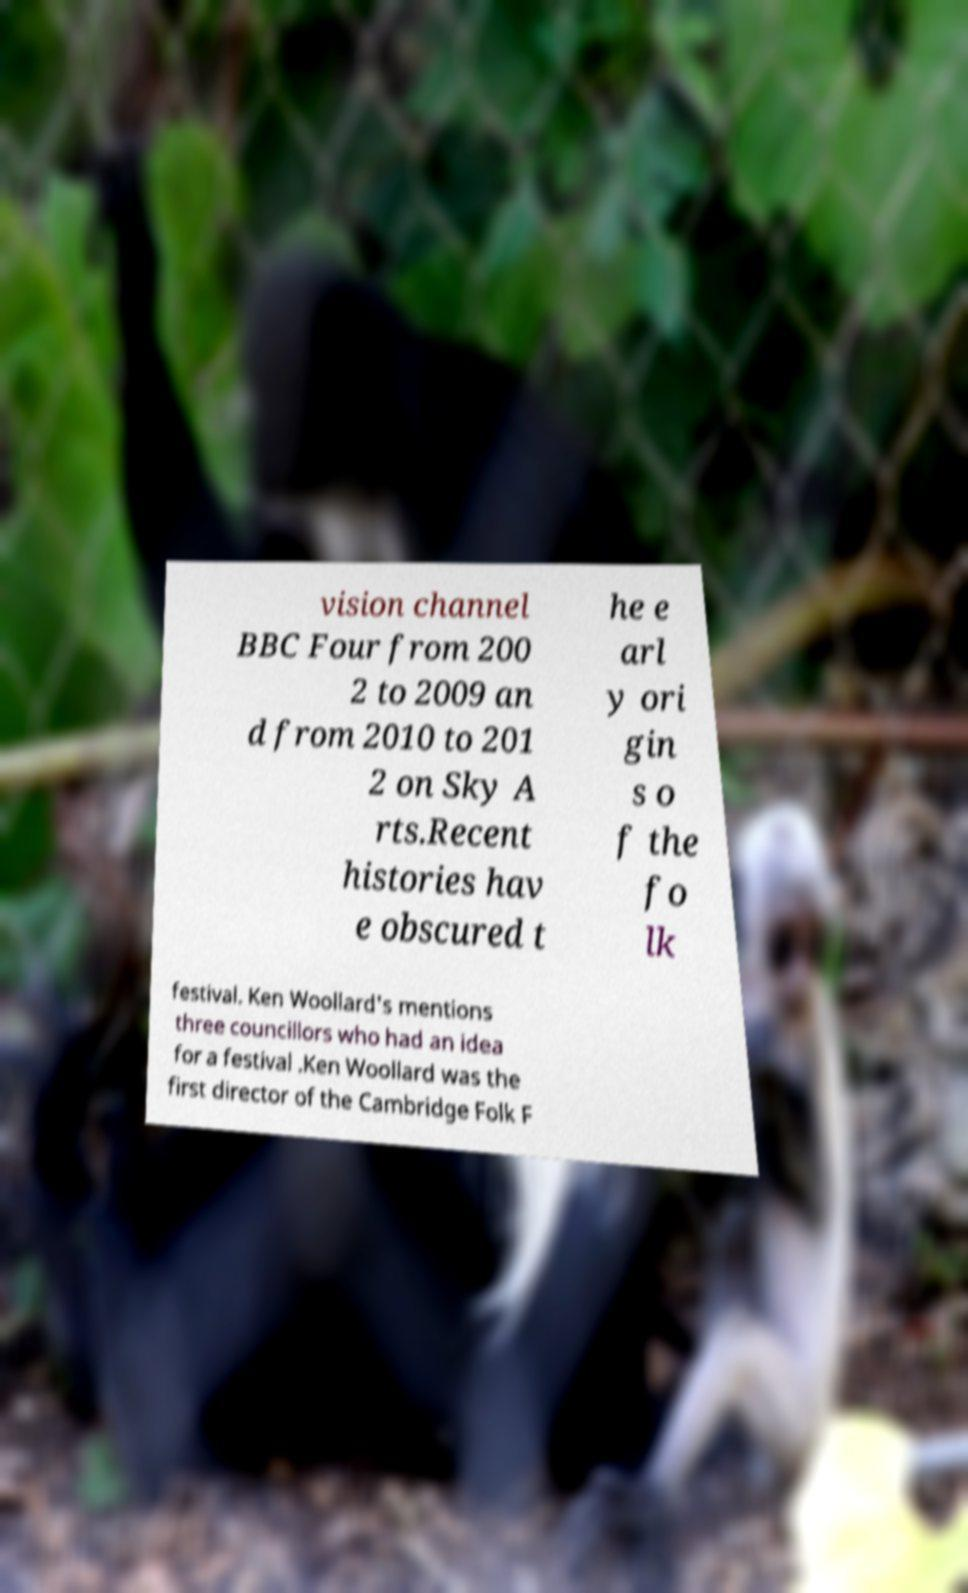Please read and relay the text visible in this image. What does it say? vision channel BBC Four from 200 2 to 2009 an d from 2010 to 201 2 on Sky A rts.Recent histories hav e obscured t he e arl y ori gin s o f the fo lk festival. Ken Woollard's mentions three councillors who had an idea for a festival .Ken Woollard was the first director of the Cambridge Folk F 